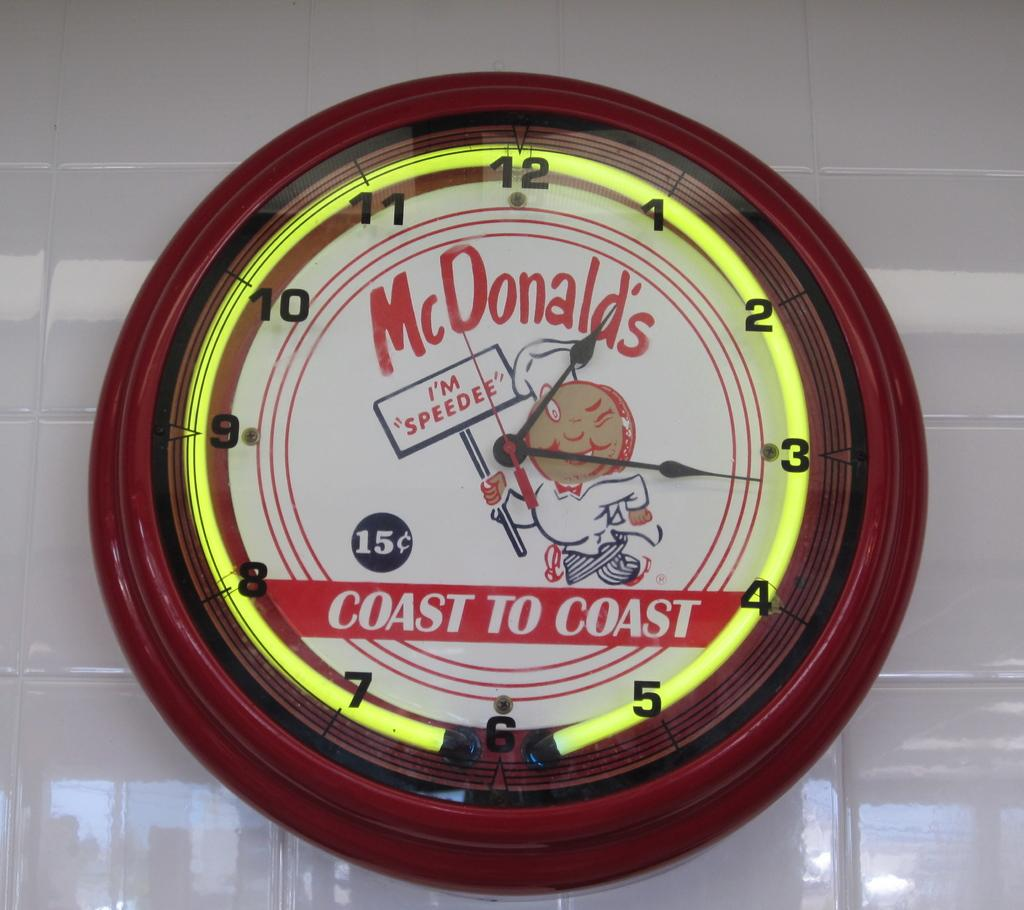<image>
Summarize the visual content of the image. An old fashioned McDonald;s clock showing the time 1:16 